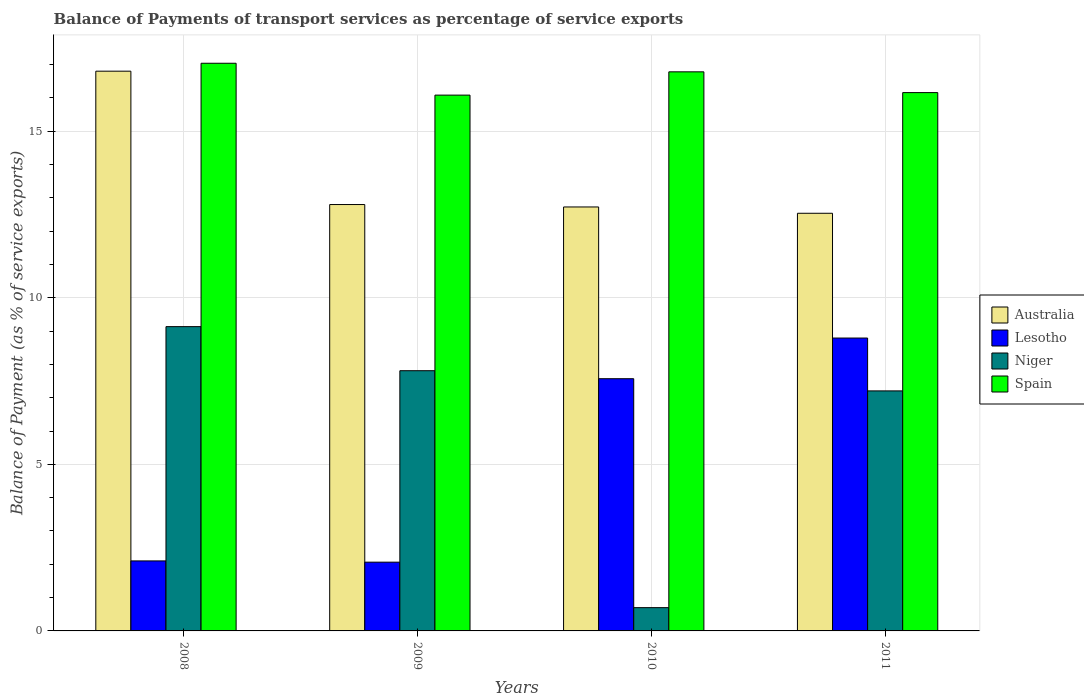Are the number of bars per tick equal to the number of legend labels?
Give a very brief answer. Yes. Are the number of bars on each tick of the X-axis equal?
Offer a terse response. Yes. How many bars are there on the 2nd tick from the left?
Offer a terse response. 4. In how many cases, is the number of bars for a given year not equal to the number of legend labels?
Keep it short and to the point. 0. What is the balance of payments of transport services in Australia in 2008?
Give a very brief answer. 16.81. Across all years, what is the maximum balance of payments of transport services in Australia?
Give a very brief answer. 16.81. Across all years, what is the minimum balance of payments of transport services in Spain?
Offer a terse response. 16.09. In which year was the balance of payments of transport services in Spain maximum?
Make the answer very short. 2008. What is the total balance of payments of transport services in Lesotho in the graph?
Your answer should be very brief. 20.53. What is the difference between the balance of payments of transport services in Niger in 2008 and that in 2011?
Provide a short and direct response. 1.93. What is the difference between the balance of payments of transport services in Spain in 2011 and the balance of payments of transport services in Niger in 2009?
Give a very brief answer. 8.35. What is the average balance of payments of transport services in Lesotho per year?
Make the answer very short. 5.13. In the year 2008, what is the difference between the balance of payments of transport services in Niger and balance of payments of transport services in Australia?
Provide a short and direct response. -7.67. What is the ratio of the balance of payments of transport services in Australia in 2008 to that in 2009?
Your answer should be very brief. 1.31. Is the difference between the balance of payments of transport services in Niger in 2009 and 2011 greater than the difference between the balance of payments of transport services in Australia in 2009 and 2011?
Provide a short and direct response. Yes. What is the difference between the highest and the second highest balance of payments of transport services in Spain?
Give a very brief answer. 0.26. What is the difference between the highest and the lowest balance of payments of transport services in Lesotho?
Ensure brevity in your answer.  6.73. What does the 3rd bar from the right in 2010 represents?
Your answer should be compact. Lesotho. How many bars are there?
Give a very brief answer. 16. Are the values on the major ticks of Y-axis written in scientific E-notation?
Ensure brevity in your answer.  No. Does the graph contain grids?
Your answer should be compact. Yes. What is the title of the graph?
Make the answer very short. Balance of Payments of transport services as percentage of service exports. Does "Dominican Republic" appear as one of the legend labels in the graph?
Your answer should be very brief. No. What is the label or title of the X-axis?
Offer a terse response. Years. What is the label or title of the Y-axis?
Make the answer very short. Balance of Payment (as % of service exports). What is the Balance of Payment (as % of service exports) in Australia in 2008?
Keep it short and to the point. 16.81. What is the Balance of Payment (as % of service exports) in Lesotho in 2008?
Your answer should be compact. 2.1. What is the Balance of Payment (as % of service exports) of Niger in 2008?
Ensure brevity in your answer.  9.14. What is the Balance of Payment (as % of service exports) in Spain in 2008?
Make the answer very short. 17.04. What is the Balance of Payment (as % of service exports) of Australia in 2009?
Provide a succinct answer. 12.8. What is the Balance of Payment (as % of service exports) of Lesotho in 2009?
Make the answer very short. 2.06. What is the Balance of Payment (as % of service exports) of Niger in 2009?
Provide a short and direct response. 7.81. What is the Balance of Payment (as % of service exports) in Spain in 2009?
Provide a succinct answer. 16.09. What is the Balance of Payment (as % of service exports) of Australia in 2010?
Offer a very short reply. 12.73. What is the Balance of Payment (as % of service exports) of Lesotho in 2010?
Your answer should be very brief. 7.57. What is the Balance of Payment (as % of service exports) of Niger in 2010?
Give a very brief answer. 0.7. What is the Balance of Payment (as % of service exports) in Spain in 2010?
Provide a succinct answer. 16.79. What is the Balance of Payment (as % of service exports) in Australia in 2011?
Your answer should be very brief. 12.54. What is the Balance of Payment (as % of service exports) of Lesotho in 2011?
Provide a short and direct response. 8.79. What is the Balance of Payment (as % of service exports) in Niger in 2011?
Provide a short and direct response. 7.21. What is the Balance of Payment (as % of service exports) of Spain in 2011?
Make the answer very short. 16.16. Across all years, what is the maximum Balance of Payment (as % of service exports) of Australia?
Offer a terse response. 16.81. Across all years, what is the maximum Balance of Payment (as % of service exports) of Lesotho?
Offer a very short reply. 8.79. Across all years, what is the maximum Balance of Payment (as % of service exports) of Niger?
Your response must be concise. 9.14. Across all years, what is the maximum Balance of Payment (as % of service exports) in Spain?
Ensure brevity in your answer.  17.04. Across all years, what is the minimum Balance of Payment (as % of service exports) in Australia?
Keep it short and to the point. 12.54. Across all years, what is the minimum Balance of Payment (as % of service exports) of Lesotho?
Your answer should be very brief. 2.06. Across all years, what is the minimum Balance of Payment (as % of service exports) of Niger?
Offer a terse response. 0.7. Across all years, what is the minimum Balance of Payment (as % of service exports) of Spain?
Your answer should be very brief. 16.09. What is the total Balance of Payment (as % of service exports) in Australia in the graph?
Provide a short and direct response. 54.87. What is the total Balance of Payment (as % of service exports) in Lesotho in the graph?
Offer a terse response. 20.53. What is the total Balance of Payment (as % of service exports) of Niger in the graph?
Ensure brevity in your answer.  24.85. What is the total Balance of Payment (as % of service exports) in Spain in the graph?
Provide a short and direct response. 66.08. What is the difference between the Balance of Payment (as % of service exports) of Australia in 2008 and that in 2009?
Provide a short and direct response. 4. What is the difference between the Balance of Payment (as % of service exports) of Lesotho in 2008 and that in 2009?
Provide a succinct answer. 0.04. What is the difference between the Balance of Payment (as % of service exports) of Niger in 2008 and that in 2009?
Offer a very short reply. 1.32. What is the difference between the Balance of Payment (as % of service exports) in Spain in 2008 and that in 2009?
Make the answer very short. 0.96. What is the difference between the Balance of Payment (as % of service exports) of Australia in 2008 and that in 2010?
Your answer should be very brief. 4.08. What is the difference between the Balance of Payment (as % of service exports) of Lesotho in 2008 and that in 2010?
Give a very brief answer. -5.47. What is the difference between the Balance of Payment (as % of service exports) of Niger in 2008 and that in 2010?
Provide a short and direct response. 8.44. What is the difference between the Balance of Payment (as % of service exports) of Spain in 2008 and that in 2010?
Your answer should be compact. 0.26. What is the difference between the Balance of Payment (as % of service exports) in Australia in 2008 and that in 2011?
Offer a very short reply. 4.27. What is the difference between the Balance of Payment (as % of service exports) of Lesotho in 2008 and that in 2011?
Your response must be concise. -6.69. What is the difference between the Balance of Payment (as % of service exports) in Niger in 2008 and that in 2011?
Offer a very short reply. 1.93. What is the difference between the Balance of Payment (as % of service exports) of Spain in 2008 and that in 2011?
Provide a short and direct response. 0.88. What is the difference between the Balance of Payment (as % of service exports) in Australia in 2009 and that in 2010?
Your answer should be very brief. 0.07. What is the difference between the Balance of Payment (as % of service exports) of Lesotho in 2009 and that in 2010?
Keep it short and to the point. -5.51. What is the difference between the Balance of Payment (as % of service exports) in Niger in 2009 and that in 2010?
Keep it short and to the point. 7.11. What is the difference between the Balance of Payment (as % of service exports) of Spain in 2009 and that in 2010?
Provide a succinct answer. -0.7. What is the difference between the Balance of Payment (as % of service exports) of Australia in 2009 and that in 2011?
Make the answer very short. 0.26. What is the difference between the Balance of Payment (as % of service exports) in Lesotho in 2009 and that in 2011?
Provide a short and direct response. -6.73. What is the difference between the Balance of Payment (as % of service exports) of Niger in 2009 and that in 2011?
Make the answer very short. 0.61. What is the difference between the Balance of Payment (as % of service exports) in Spain in 2009 and that in 2011?
Make the answer very short. -0.08. What is the difference between the Balance of Payment (as % of service exports) in Australia in 2010 and that in 2011?
Your answer should be very brief. 0.19. What is the difference between the Balance of Payment (as % of service exports) in Lesotho in 2010 and that in 2011?
Offer a terse response. -1.22. What is the difference between the Balance of Payment (as % of service exports) in Niger in 2010 and that in 2011?
Offer a terse response. -6.51. What is the difference between the Balance of Payment (as % of service exports) in Spain in 2010 and that in 2011?
Ensure brevity in your answer.  0.62. What is the difference between the Balance of Payment (as % of service exports) in Australia in 2008 and the Balance of Payment (as % of service exports) in Lesotho in 2009?
Provide a succinct answer. 14.74. What is the difference between the Balance of Payment (as % of service exports) of Australia in 2008 and the Balance of Payment (as % of service exports) of Niger in 2009?
Give a very brief answer. 8.99. What is the difference between the Balance of Payment (as % of service exports) in Australia in 2008 and the Balance of Payment (as % of service exports) in Spain in 2009?
Provide a short and direct response. 0.72. What is the difference between the Balance of Payment (as % of service exports) in Lesotho in 2008 and the Balance of Payment (as % of service exports) in Niger in 2009?
Keep it short and to the point. -5.71. What is the difference between the Balance of Payment (as % of service exports) of Lesotho in 2008 and the Balance of Payment (as % of service exports) of Spain in 2009?
Make the answer very short. -13.98. What is the difference between the Balance of Payment (as % of service exports) in Niger in 2008 and the Balance of Payment (as % of service exports) in Spain in 2009?
Ensure brevity in your answer.  -6.95. What is the difference between the Balance of Payment (as % of service exports) in Australia in 2008 and the Balance of Payment (as % of service exports) in Lesotho in 2010?
Provide a succinct answer. 9.23. What is the difference between the Balance of Payment (as % of service exports) in Australia in 2008 and the Balance of Payment (as % of service exports) in Niger in 2010?
Your response must be concise. 16.11. What is the difference between the Balance of Payment (as % of service exports) of Australia in 2008 and the Balance of Payment (as % of service exports) of Spain in 2010?
Offer a terse response. 0.02. What is the difference between the Balance of Payment (as % of service exports) in Lesotho in 2008 and the Balance of Payment (as % of service exports) in Niger in 2010?
Keep it short and to the point. 1.4. What is the difference between the Balance of Payment (as % of service exports) of Lesotho in 2008 and the Balance of Payment (as % of service exports) of Spain in 2010?
Ensure brevity in your answer.  -14.68. What is the difference between the Balance of Payment (as % of service exports) in Niger in 2008 and the Balance of Payment (as % of service exports) in Spain in 2010?
Provide a short and direct response. -7.65. What is the difference between the Balance of Payment (as % of service exports) of Australia in 2008 and the Balance of Payment (as % of service exports) of Lesotho in 2011?
Provide a short and direct response. 8.01. What is the difference between the Balance of Payment (as % of service exports) of Australia in 2008 and the Balance of Payment (as % of service exports) of Niger in 2011?
Provide a succinct answer. 9.6. What is the difference between the Balance of Payment (as % of service exports) of Australia in 2008 and the Balance of Payment (as % of service exports) of Spain in 2011?
Keep it short and to the point. 0.64. What is the difference between the Balance of Payment (as % of service exports) in Lesotho in 2008 and the Balance of Payment (as % of service exports) in Niger in 2011?
Keep it short and to the point. -5.1. What is the difference between the Balance of Payment (as % of service exports) of Lesotho in 2008 and the Balance of Payment (as % of service exports) of Spain in 2011?
Provide a short and direct response. -14.06. What is the difference between the Balance of Payment (as % of service exports) of Niger in 2008 and the Balance of Payment (as % of service exports) of Spain in 2011?
Offer a terse response. -7.03. What is the difference between the Balance of Payment (as % of service exports) in Australia in 2009 and the Balance of Payment (as % of service exports) in Lesotho in 2010?
Keep it short and to the point. 5.23. What is the difference between the Balance of Payment (as % of service exports) in Australia in 2009 and the Balance of Payment (as % of service exports) in Niger in 2010?
Give a very brief answer. 12.1. What is the difference between the Balance of Payment (as % of service exports) of Australia in 2009 and the Balance of Payment (as % of service exports) of Spain in 2010?
Your answer should be compact. -3.98. What is the difference between the Balance of Payment (as % of service exports) in Lesotho in 2009 and the Balance of Payment (as % of service exports) in Niger in 2010?
Give a very brief answer. 1.37. What is the difference between the Balance of Payment (as % of service exports) of Lesotho in 2009 and the Balance of Payment (as % of service exports) of Spain in 2010?
Your answer should be compact. -14.72. What is the difference between the Balance of Payment (as % of service exports) of Niger in 2009 and the Balance of Payment (as % of service exports) of Spain in 2010?
Your answer should be compact. -8.97. What is the difference between the Balance of Payment (as % of service exports) of Australia in 2009 and the Balance of Payment (as % of service exports) of Lesotho in 2011?
Your answer should be very brief. 4.01. What is the difference between the Balance of Payment (as % of service exports) in Australia in 2009 and the Balance of Payment (as % of service exports) in Niger in 2011?
Keep it short and to the point. 5.59. What is the difference between the Balance of Payment (as % of service exports) of Australia in 2009 and the Balance of Payment (as % of service exports) of Spain in 2011?
Ensure brevity in your answer.  -3.36. What is the difference between the Balance of Payment (as % of service exports) of Lesotho in 2009 and the Balance of Payment (as % of service exports) of Niger in 2011?
Make the answer very short. -5.14. What is the difference between the Balance of Payment (as % of service exports) of Lesotho in 2009 and the Balance of Payment (as % of service exports) of Spain in 2011?
Keep it short and to the point. -14.1. What is the difference between the Balance of Payment (as % of service exports) of Niger in 2009 and the Balance of Payment (as % of service exports) of Spain in 2011?
Provide a succinct answer. -8.35. What is the difference between the Balance of Payment (as % of service exports) in Australia in 2010 and the Balance of Payment (as % of service exports) in Lesotho in 2011?
Make the answer very short. 3.94. What is the difference between the Balance of Payment (as % of service exports) of Australia in 2010 and the Balance of Payment (as % of service exports) of Niger in 2011?
Ensure brevity in your answer.  5.52. What is the difference between the Balance of Payment (as % of service exports) in Australia in 2010 and the Balance of Payment (as % of service exports) in Spain in 2011?
Your response must be concise. -3.43. What is the difference between the Balance of Payment (as % of service exports) of Lesotho in 2010 and the Balance of Payment (as % of service exports) of Niger in 2011?
Your response must be concise. 0.37. What is the difference between the Balance of Payment (as % of service exports) of Lesotho in 2010 and the Balance of Payment (as % of service exports) of Spain in 2011?
Your answer should be compact. -8.59. What is the difference between the Balance of Payment (as % of service exports) of Niger in 2010 and the Balance of Payment (as % of service exports) of Spain in 2011?
Provide a short and direct response. -15.46. What is the average Balance of Payment (as % of service exports) in Australia per year?
Provide a short and direct response. 13.72. What is the average Balance of Payment (as % of service exports) of Lesotho per year?
Ensure brevity in your answer.  5.13. What is the average Balance of Payment (as % of service exports) in Niger per year?
Offer a very short reply. 6.21. What is the average Balance of Payment (as % of service exports) in Spain per year?
Provide a short and direct response. 16.52. In the year 2008, what is the difference between the Balance of Payment (as % of service exports) of Australia and Balance of Payment (as % of service exports) of Lesotho?
Provide a succinct answer. 14.7. In the year 2008, what is the difference between the Balance of Payment (as % of service exports) of Australia and Balance of Payment (as % of service exports) of Niger?
Your answer should be compact. 7.67. In the year 2008, what is the difference between the Balance of Payment (as % of service exports) of Australia and Balance of Payment (as % of service exports) of Spain?
Your answer should be very brief. -0.24. In the year 2008, what is the difference between the Balance of Payment (as % of service exports) of Lesotho and Balance of Payment (as % of service exports) of Niger?
Offer a terse response. -7.03. In the year 2008, what is the difference between the Balance of Payment (as % of service exports) in Lesotho and Balance of Payment (as % of service exports) in Spain?
Keep it short and to the point. -14.94. In the year 2008, what is the difference between the Balance of Payment (as % of service exports) in Niger and Balance of Payment (as % of service exports) in Spain?
Provide a succinct answer. -7.91. In the year 2009, what is the difference between the Balance of Payment (as % of service exports) in Australia and Balance of Payment (as % of service exports) in Lesotho?
Provide a short and direct response. 10.74. In the year 2009, what is the difference between the Balance of Payment (as % of service exports) in Australia and Balance of Payment (as % of service exports) in Niger?
Keep it short and to the point. 4.99. In the year 2009, what is the difference between the Balance of Payment (as % of service exports) in Australia and Balance of Payment (as % of service exports) in Spain?
Ensure brevity in your answer.  -3.29. In the year 2009, what is the difference between the Balance of Payment (as % of service exports) in Lesotho and Balance of Payment (as % of service exports) in Niger?
Give a very brief answer. -5.75. In the year 2009, what is the difference between the Balance of Payment (as % of service exports) in Lesotho and Balance of Payment (as % of service exports) in Spain?
Ensure brevity in your answer.  -14.02. In the year 2009, what is the difference between the Balance of Payment (as % of service exports) in Niger and Balance of Payment (as % of service exports) in Spain?
Offer a terse response. -8.27. In the year 2010, what is the difference between the Balance of Payment (as % of service exports) of Australia and Balance of Payment (as % of service exports) of Lesotho?
Your answer should be very brief. 5.16. In the year 2010, what is the difference between the Balance of Payment (as % of service exports) of Australia and Balance of Payment (as % of service exports) of Niger?
Offer a terse response. 12.03. In the year 2010, what is the difference between the Balance of Payment (as % of service exports) in Australia and Balance of Payment (as % of service exports) in Spain?
Provide a short and direct response. -4.06. In the year 2010, what is the difference between the Balance of Payment (as % of service exports) in Lesotho and Balance of Payment (as % of service exports) in Niger?
Give a very brief answer. 6.87. In the year 2010, what is the difference between the Balance of Payment (as % of service exports) in Lesotho and Balance of Payment (as % of service exports) in Spain?
Your response must be concise. -9.21. In the year 2010, what is the difference between the Balance of Payment (as % of service exports) of Niger and Balance of Payment (as % of service exports) of Spain?
Your answer should be very brief. -16.09. In the year 2011, what is the difference between the Balance of Payment (as % of service exports) in Australia and Balance of Payment (as % of service exports) in Lesotho?
Offer a very short reply. 3.75. In the year 2011, what is the difference between the Balance of Payment (as % of service exports) of Australia and Balance of Payment (as % of service exports) of Niger?
Provide a succinct answer. 5.33. In the year 2011, what is the difference between the Balance of Payment (as % of service exports) in Australia and Balance of Payment (as % of service exports) in Spain?
Offer a terse response. -3.62. In the year 2011, what is the difference between the Balance of Payment (as % of service exports) of Lesotho and Balance of Payment (as % of service exports) of Niger?
Your response must be concise. 1.59. In the year 2011, what is the difference between the Balance of Payment (as % of service exports) of Lesotho and Balance of Payment (as % of service exports) of Spain?
Make the answer very short. -7.37. In the year 2011, what is the difference between the Balance of Payment (as % of service exports) of Niger and Balance of Payment (as % of service exports) of Spain?
Your response must be concise. -8.96. What is the ratio of the Balance of Payment (as % of service exports) of Australia in 2008 to that in 2009?
Your response must be concise. 1.31. What is the ratio of the Balance of Payment (as % of service exports) of Lesotho in 2008 to that in 2009?
Your response must be concise. 1.02. What is the ratio of the Balance of Payment (as % of service exports) in Niger in 2008 to that in 2009?
Provide a succinct answer. 1.17. What is the ratio of the Balance of Payment (as % of service exports) of Spain in 2008 to that in 2009?
Provide a short and direct response. 1.06. What is the ratio of the Balance of Payment (as % of service exports) of Australia in 2008 to that in 2010?
Make the answer very short. 1.32. What is the ratio of the Balance of Payment (as % of service exports) in Lesotho in 2008 to that in 2010?
Provide a short and direct response. 0.28. What is the ratio of the Balance of Payment (as % of service exports) in Niger in 2008 to that in 2010?
Your answer should be very brief. 13.07. What is the ratio of the Balance of Payment (as % of service exports) of Spain in 2008 to that in 2010?
Ensure brevity in your answer.  1.02. What is the ratio of the Balance of Payment (as % of service exports) in Australia in 2008 to that in 2011?
Your answer should be compact. 1.34. What is the ratio of the Balance of Payment (as % of service exports) in Lesotho in 2008 to that in 2011?
Offer a terse response. 0.24. What is the ratio of the Balance of Payment (as % of service exports) of Niger in 2008 to that in 2011?
Provide a short and direct response. 1.27. What is the ratio of the Balance of Payment (as % of service exports) in Spain in 2008 to that in 2011?
Offer a very short reply. 1.05. What is the ratio of the Balance of Payment (as % of service exports) in Australia in 2009 to that in 2010?
Give a very brief answer. 1.01. What is the ratio of the Balance of Payment (as % of service exports) of Lesotho in 2009 to that in 2010?
Keep it short and to the point. 0.27. What is the ratio of the Balance of Payment (as % of service exports) in Niger in 2009 to that in 2010?
Your answer should be compact. 11.18. What is the ratio of the Balance of Payment (as % of service exports) in Spain in 2009 to that in 2010?
Your answer should be very brief. 0.96. What is the ratio of the Balance of Payment (as % of service exports) in Australia in 2009 to that in 2011?
Give a very brief answer. 1.02. What is the ratio of the Balance of Payment (as % of service exports) in Lesotho in 2009 to that in 2011?
Provide a short and direct response. 0.23. What is the ratio of the Balance of Payment (as % of service exports) in Niger in 2009 to that in 2011?
Your response must be concise. 1.08. What is the ratio of the Balance of Payment (as % of service exports) in Spain in 2009 to that in 2011?
Ensure brevity in your answer.  1. What is the ratio of the Balance of Payment (as % of service exports) in Australia in 2010 to that in 2011?
Ensure brevity in your answer.  1.02. What is the ratio of the Balance of Payment (as % of service exports) of Lesotho in 2010 to that in 2011?
Provide a succinct answer. 0.86. What is the ratio of the Balance of Payment (as % of service exports) of Niger in 2010 to that in 2011?
Provide a short and direct response. 0.1. What is the ratio of the Balance of Payment (as % of service exports) in Spain in 2010 to that in 2011?
Your response must be concise. 1.04. What is the difference between the highest and the second highest Balance of Payment (as % of service exports) in Australia?
Give a very brief answer. 4. What is the difference between the highest and the second highest Balance of Payment (as % of service exports) of Lesotho?
Give a very brief answer. 1.22. What is the difference between the highest and the second highest Balance of Payment (as % of service exports) in Niger?
Your answer should be very brief. 1.32. What is the difference between the highest and the second highest Balance of Payment (as % of service exports) of Spain?
Your response must be concise. 0.26. What is the difference between the highest and the lowest Balance of Payment (as % of service exports) in Australia?
Provide a short and direct response. 4.27. What is the difference between the highest and the lowest Balance of Payment (as % of service exports) in Lesotho?
Your response must be concise. 6.73. What is the difference between the highest and the lowest Balance of Payment (as % of service exports) in Niger?
Provide a short and direct response. 8.44. What is the difference between the highest and the lowest Balance of Payment (as % of service exports) of Spain?
Give a very brief answer. 0.96. 